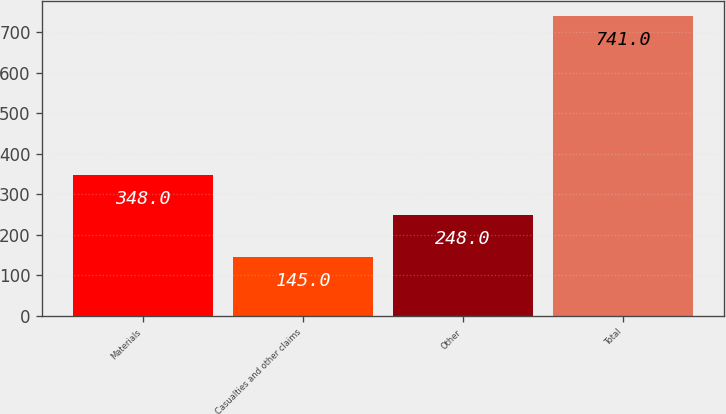Convert chart to OTSL. <chart><loc_0><loc_0><loc_500><loc_500><bar_chart><fcel>Materials<fcel>Casualties and other claims<fcel>Other<fcel>Total<nl><fcel>348<fcel>145<fcel>248<fcel>741<nl></chart> 